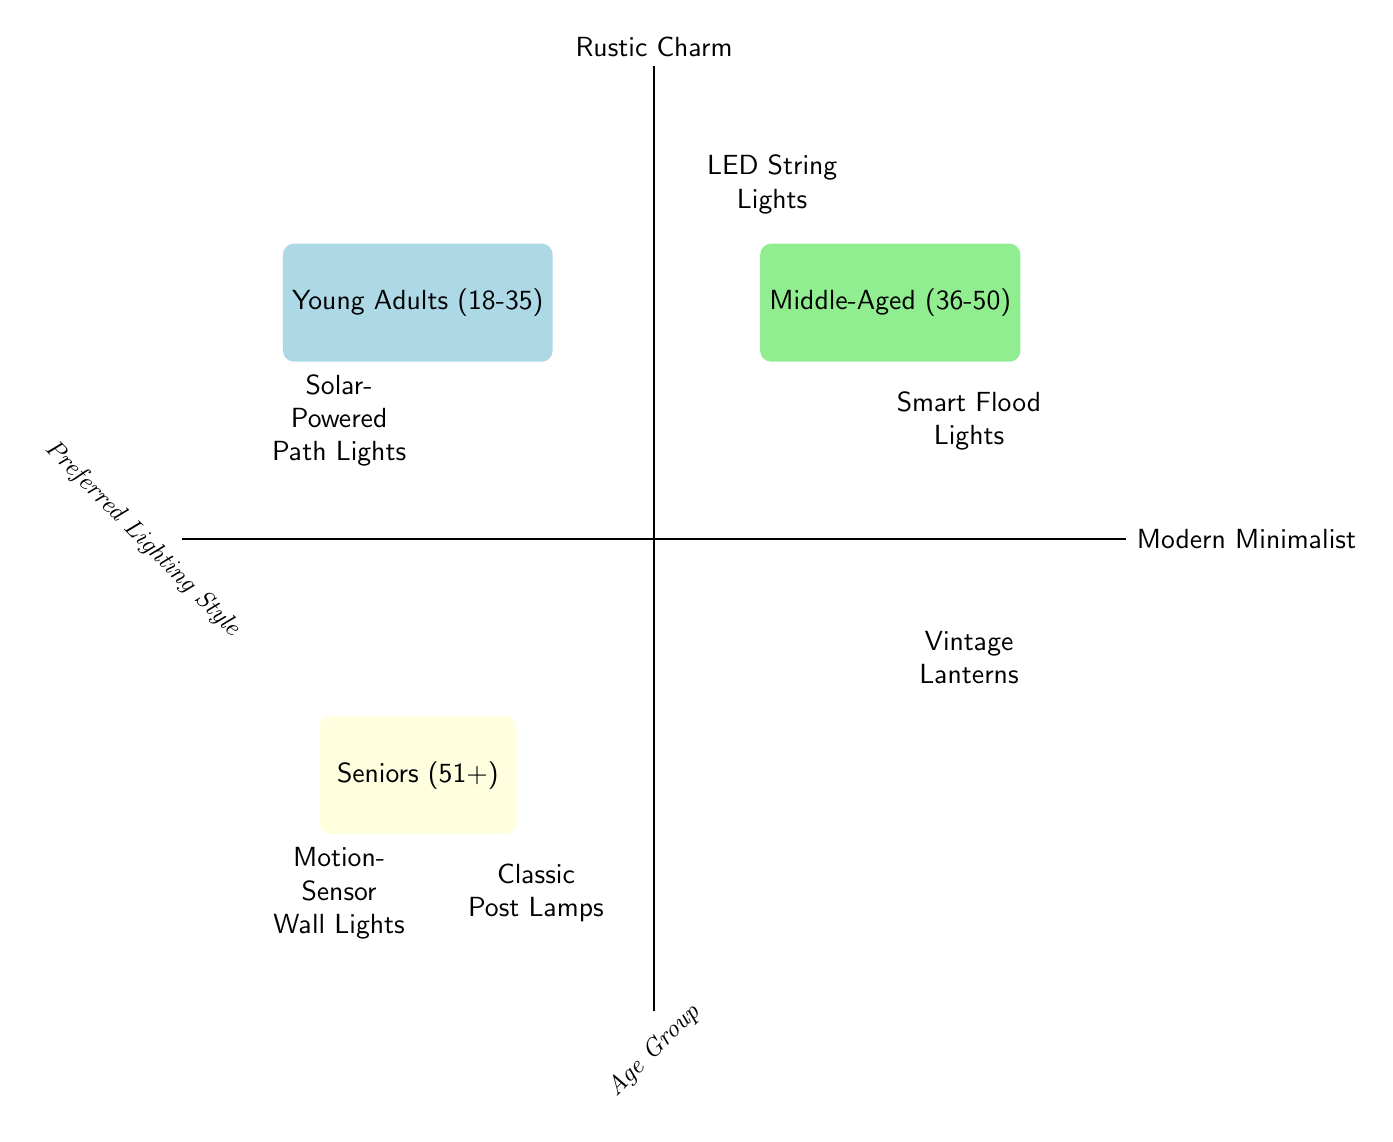What's the preferred lighting style for Young Adults? The diagram shows that Young Adults (18-35) prefer the Modern Minimalist style, which includes Solar-Powered Path Lights.
Answer: Solar-Powered Path Lights What lighting style do Middle-Aged customers prefer? According to the diagram, the Middle-Aged (36-50) group prefers the Modern Minimalist style, represented by Smart Flood Lights.
Answer: Smart Flood Lights Which age group prefers Classic Post Lamps? The Seniors (51+) age group, located in the bottom-left quadrant of the chart, prefer Classic Post Lamps, classified under Rustic Charm.
Answer: Seniors (51+) How many lighting styles are represented in the diagram? The diagram displays two lighting styles: Modern Minimalist and Rustic Charm, making a total of two styles.
Answer: 2 What is the relation between Modern Minimalist and the age group of Seniors? In the diagram, Seniors (51+) do not choose anything from the Modern Minimalist category; they prefer Rustic Charm, specifically Classic Post Lamps.
Answer: No relation Which age group has the widest variety of lighting choices? Analyzing the age groups featured in the diagram, Young Adults (18-35) and Middle-Aged (36-50) both have two distinct lighting options, while Seniors (51+) prefer only one option from each style. Thus, they are equivalent.
Answer: Young Adults and Middle-Aged Which lighting style is associated with the least number of age groups? The diagram indicates that the lighting style Classic Post Lamps is only associated with Seniors (51+), thus limiting its reach compared to the other styles linked to multiple age groups.
Answer: Classic Post Lamps What type of lighting is preferred by the oldest age group? The diagram clearly shows that the Seniors (51+) group prefers Classic Post Lamps, which falls under Rustic Charm.
Answer: Classic Post Lamps What lighting option is common to both Young Adults and Middle-Aged groups? While they each have distinct preferences, both age groups share a preference for the Modern Minimalist style, showcased by different lighting options.
Answer: Modern Minimalist 